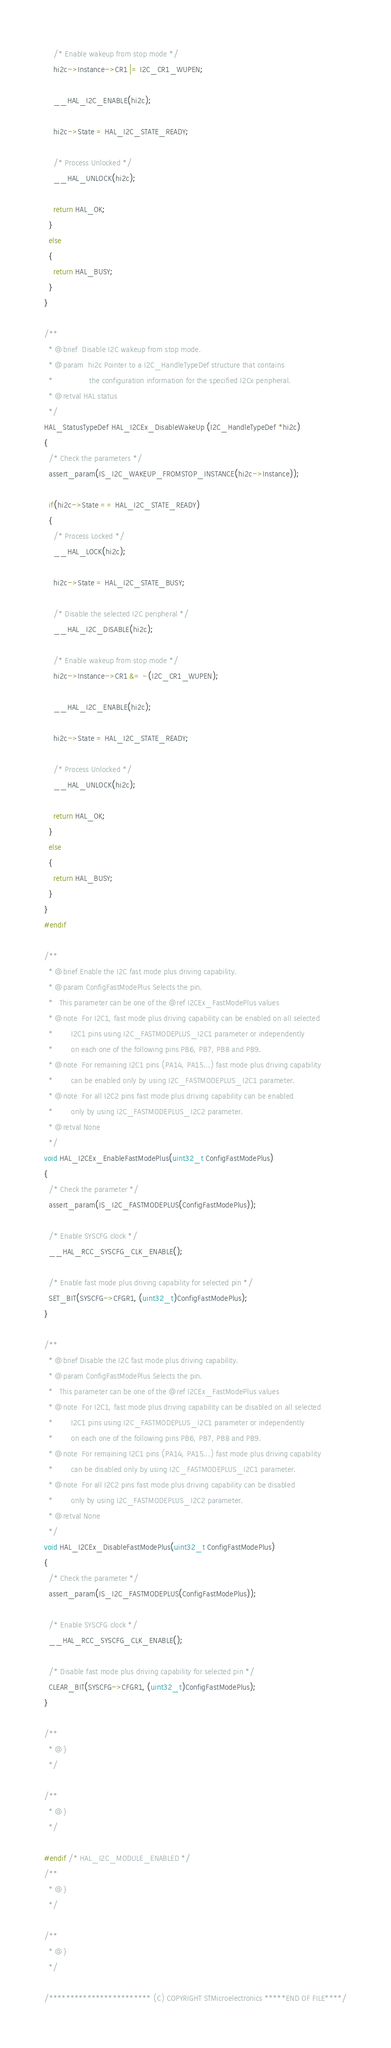<code> <loc_0><loc_0><loc_500><loc_500><_C_>    /* Enable wakeup from stop mode */
    hi2c->Instance->CR1 |= I2C_CR1_WUPEN;

    __HAL_I2C_ENABLE(hi2c);

    hi2c->State = HAL_I2C_STATE_READY;

    /* Process Unlocked */
    __HAL_UNLOCK(hi2c);

    return HAL_OK;
  }
  else
  {
    return HAL_BUSY;
  }
}

/**
  * @brief  Disable I2C wakeup from stop mode.
  * @param  hi2c Pointer to a I2C_HandleTypeDef structure that contains
  *                the configuration information for the specified I2Cx peripheral.
  * @retval HAL status
  */
HAL_StatusTypeDef HAL_I2CEx_DisableWakeUp (I2C_HandleTypeDef *hi2c)
{
  /* Check the parameters */
  assert_param(IS_I2C_WAKEUP_FROMSTOP_INSTANCE(hi2c->Instance));

  if(hi2c->State == HAL_I2C_STATE_READY)
  {
    /* Process Locked */
    __HAL_LOCK(hi2c);

    hi2c->State = HAL_I2C_STATE_BUSY;

    /* Disable the selected I2C peripheral */
    __HAL_I2C_DISABLE(hi2c);

    /* Enable wakeup from stop mode */
    hi2c->Instance->CR1 &= ~(I2C_CR1_WUPEN);

    __HAL_I2C_ENABLE(hi2c); 

    hi2c->State = HAL_I2C_STATE_READY;

    /* Process Unlocked */
    __HAL_UNLOCK(hi2c);

    return HAL_OK;
  }
  else
  {
    return HAL_BUSY;
  }
}
#endif

/**
  * @brief Enable the I2C fast mode plus driving capability.
  * @param ConfigFastModePlus Selects the pin.
  *   This parameter can be one of the @ref I2CEx_FastModePlus values
  * @note  For I2C1, fast mode plus driving capability can be enabled on all selected
  *        I2C1 pins using I2C_FASTMODEPLUS_I2C1 parameter or independently
  *        on each one of the following pins PB6, PB7, PB8 and PB9.
  * @note  For remaining I2C1 pins (PA14, PA15...) fast mode plus driving capability
  *        can be enabled only by using I2C_FASTMODEPLUS_I2C1 parameter.
  * @note  For all I2C2 pins fast mode plus driving capability can be enabled
  *        only by using I2C_FASTMODEPLUS_I2C2 parameter.
  * @retval None
  */
void HAL_I2CEx_EnableFastModePlus(uint32_t ConfigFastModePlus)
{
  /* Check the parameter */
  assert_param(IS_I2C_FASTMODEPLUS(ConfigFastModePlus));

  /* Enable SYSCFG clock */
  __HAL_RCC_SYSCFG_CLK_ENABLE();

  /* Enable fast mode plus driving capability for selected pin */
  SET_BIT(SYSCFG->CFGR1, (uint32_t)ConfigFastModePlus);
}

/**
  * @brief Disable the I2C fast mode plus driving capability.
  * @param ConfigFastModePlus Selects the pin.
  *   This parameter can be one of the @ref I2CEx_FastModePlus values
  * @note  For I2C1, fast mode plus driving capability can be disabled on all selected
  *        I2C1 pins using I2C_FASTMODEPLUS_I2C1 parameter or independently
  *        on each one of the following pins PB6, PB7, PB8 and PB9.
  * @note  For remaining I2C1 pins (PA14, PA15...) fast mode plus driving capability
  *        can be disabled only by using I2C_FASTMODEPLUS_I2C1 parameter.
  * @note  For all I2C2 pins fast mode plus driving capability can be disabled
  *        only by using I2C_FASTMODEPLUS_I2C2 parameter.
  * @retval None
  */
void HAL_I2CEx_DisableFastModePlus(uint32_t ConfigFastModePlus)
{
  /* Check the parameter */
  assert_param(IS_I2C_FASTMODEPLUS(ConfigFastModePlus));

  /* Enable SYSCFG clock */
  __HAL_RCC_SYSCFG_CLK_ENABLE();

  /* Disable fast mode plus driving capability for selected pin */
  CLEAR_BIT(SYSCFG->CFGR1, (uint32_t)ConfigFastModePlus);
}

/**
  * @}
  */

/**
  * @}
  */

#endif /* HAL_I2C_MODULE_ENABLED */
/**
  * @}
  */

/**
  * @}
  */

/************************ (C) COPYRIGHT STMicroelectronics *****END OF FILE****/
</code> 